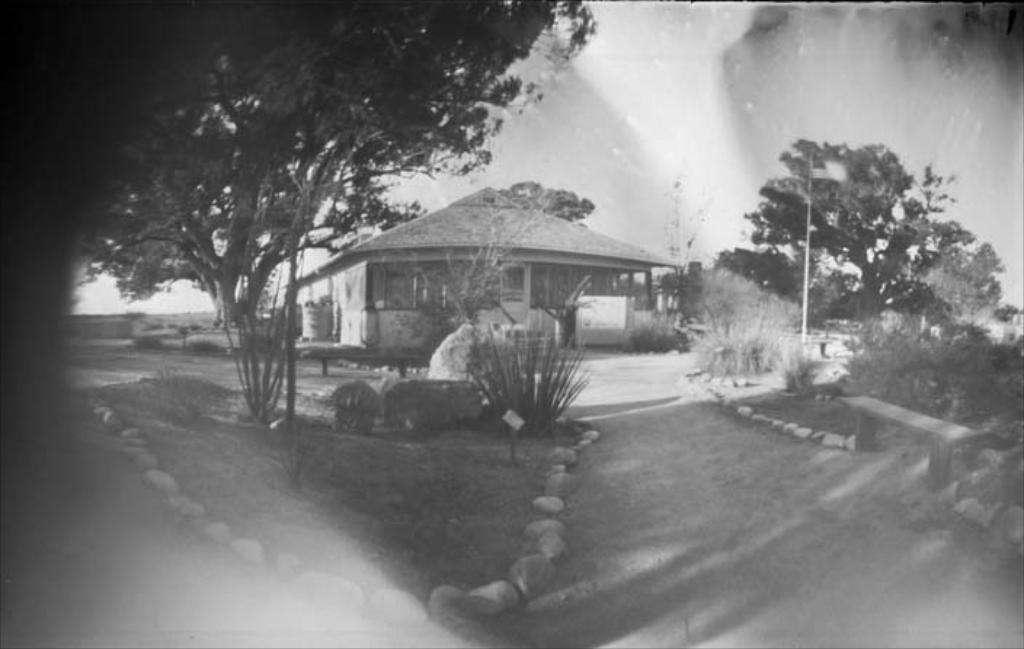What is the main structure in the center of the image? There is a house in the center of the image. What are the basic components of the house? The house has a roof and walls. What other objects can be seen in the image? There is a tank, a banner, and a door visible in the image. What is the background of the image composed of? The background includes sky, clouds, trees, poles, plants, stones, and grass. Is there any seating present in the background? Yes, there is a bench in the background. What type of stocking is hanging from the roof of the house in the image? There is no stocking hanging from the roof of the house in the image. Can you describe the curve of the smile on the door in the image? There is no smile present on the door in the image. 